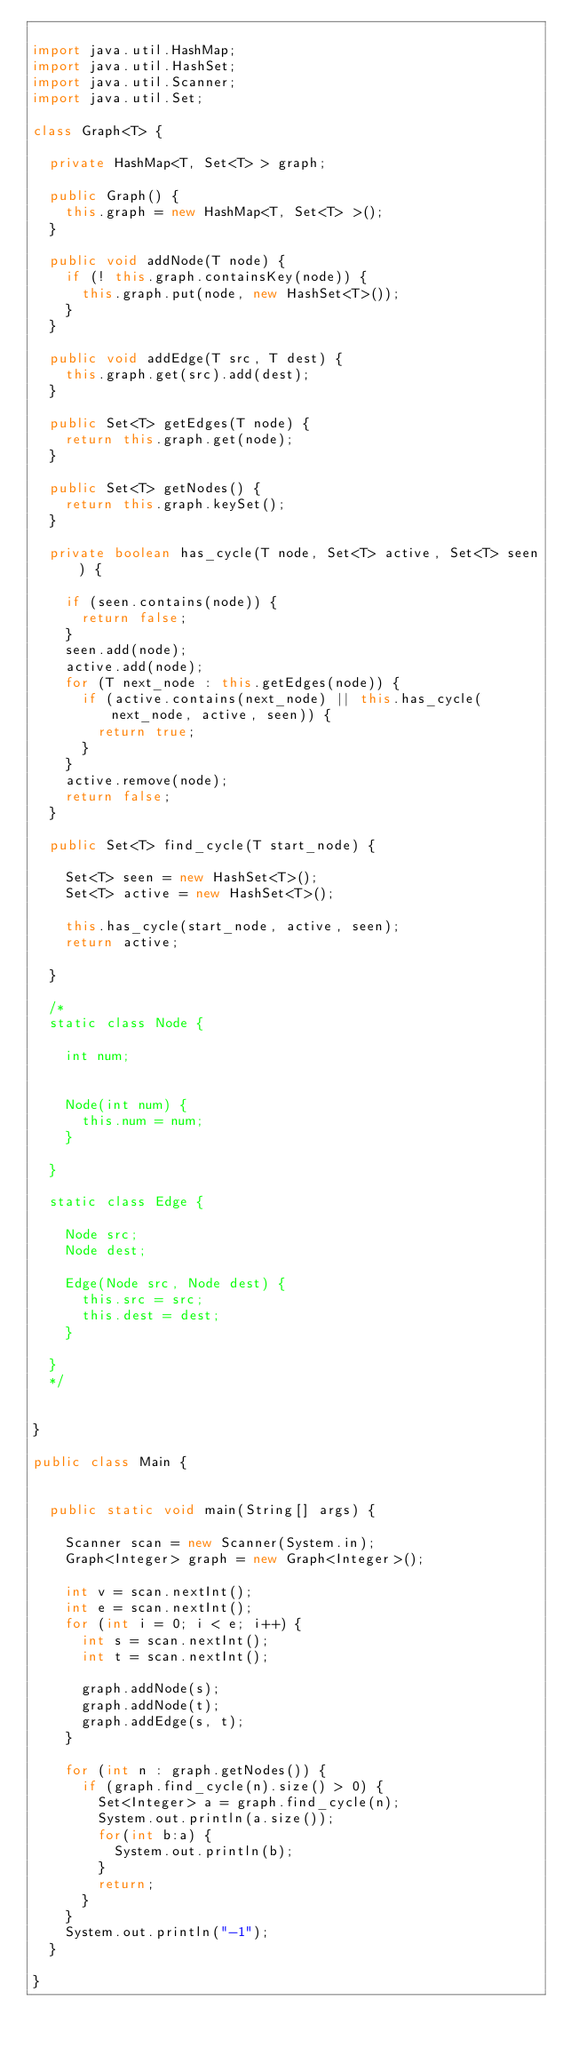Convert code to text. <code><loc_0><loc_0><loc_500><loc_500><_Java_>
import java.util.HashMap;
import java.util.HashSet;
import java.util.Scanner;
import java.util.Set;

class Graph<T> {

	private HashMap<T, Set<T> > graph;

	public Graph() {
		this.graph = new HashMap<T, Set<T> >();
	}

	public void addNode(T node) {
		if (! this.graph.containsKey(node)) {
			this.graph.put(node, new HashSet<T>());
		}
	}

	public void addEdge(T src, T dest) {
		this.graph.get(src).add(dest);
	}

	public Set<T> getEdges(T node) {
		return this.graph.get(node);
	}

	public Set<T> getNodes() {
		return this.graph.keySet();
	}

	private boolean has_cycle(T node, Set<T> active, Set<T> seen) {

		if (seen.contains(node)) {
			return false;
		}
		seen.add(node);
		active.add(node);
		for (T next_node : this.getEdges(node)) {
			if (active.contains(next_node) || this.has_cycle(next_node, active, seen)) {
				return true;
			}
		}
		active.remove(node);
		return false;
	}

	public Set<T> find_cycle(T start_node) {

		Set<T> seen = new HashSet<T>();
		Set<T> active = new HashSet<T>();

		this.has_cycle(start_node, active, seen);
		return active;

	}

	/*
	static class Node {

		int num;


		Node(int num) {
			this.num = num;
		}

	}

	static class Edge {

		Node src;
		Node dest;

		Edge(Node src, Node dest) {
			this.src = src;
			this.dest = dest;
		}

	}
	*/


}

public class Main {


	public static void main(String[] args) {

		Scanner scan = new Scanner(System.in);
		Graph<Integer> graph = new Graph<Integer>();

		int v = scan.nextInt();
		int e = scan.nextInt();
		for (int i = 0; i < e; i++) {
			int s = scan.nextInt();
			int t = scan.nextInt();

			graph.addNode(s);
			graph.addNode(t);
			graph.addEdge(s, t);
		}

		for (int n : graph.getNodes()) {
			if (graph.find_cycle(n).size() > 0) {
				Set<Integer> a = graph.find_cycle(n);
				System.out.println(a.size());
				for(int b:a) {
					System.out.println(b);
				}
				return;
			}
		}
		System.out.println("-1");
	}

}
</code> 